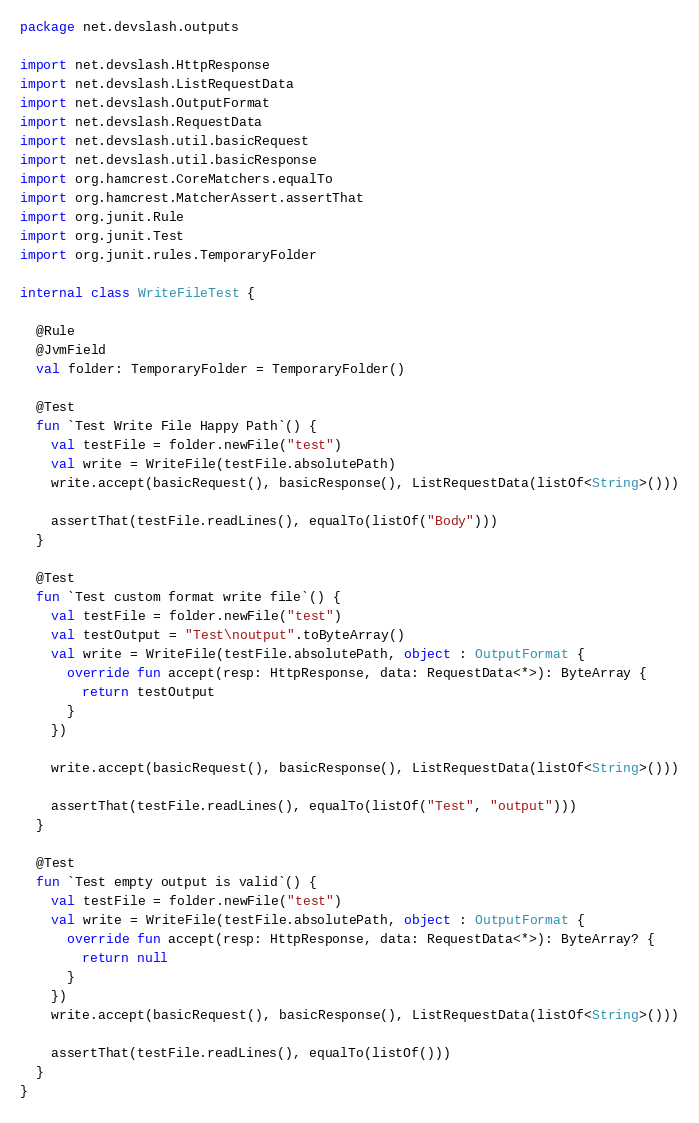Convert code to text. <code><loc_0><loc_0><loc_500><loc_500><_Kotlin_>package net.devslash.outputs

import net.devslash.HttpResponse
import net.devslash.ListRequestData
import net.devslash.OutputFormat
import net.devslash.RequestData
import net.devslash.util.basicRequest
import net.devslash.util.basicResponse
import org.hamcrest.CoreMatchers.equalTo
import org.hamcrest.MatcherAssert.assertThat
import org.junit.Rule
import org.junit.Test
import org.junit.rules.TemporaryFolder

internal class WriteFileTest {

  @Rule
  @JvmField
  val folder: TemporaryFolder = TemporaryFolder()

  @Test
  fun `Test Write File Happy Path`() {
    val testFile = folder.newFile("test")
    val write = WriteFile(testFile.absolutePath)
    write.accept(basicRequest(), basicResponse(), ListRequestData(listOf<String>()))

    assertThat(testFile.readLines(), equalTo(listOf("Body")))
  }

  @Test
  fun `Test custom format write file`() {
    val testFile = folder.newFile("test")
    val testOutput = "Test\noutput".toByteArray()
    val write = WriteFile(testFile.absolutePath, object : OutputFormat {
      override fun accept(resp: HttpResponse, data: RequestData<*>): ByteArray {
        return testOutput
      }
    })

    write.accept(basicRequest(), basicResponse(), ListRequestData(listOf<String>()))

    assertThat(testFile.readLines(), equalTo(listOf("Test", "output")))
  }

  @Test
  fun `Test empty output is valid`() {
    val testFile = folder.newFile("test")
    val write = WriteFile(testFile.absolutePath, object : OutputFormat {
      override fun accept(resp: HttpResponse, data: RequestData<*>): ByteArray? {
        return null
      }
    })
    write.accept(basicRequest(), basicResponse(), ListRequestData(listOf<String>()))

    assertThat(testFile.readLines(), equalTo(listOf()))
  }
}
</code> 